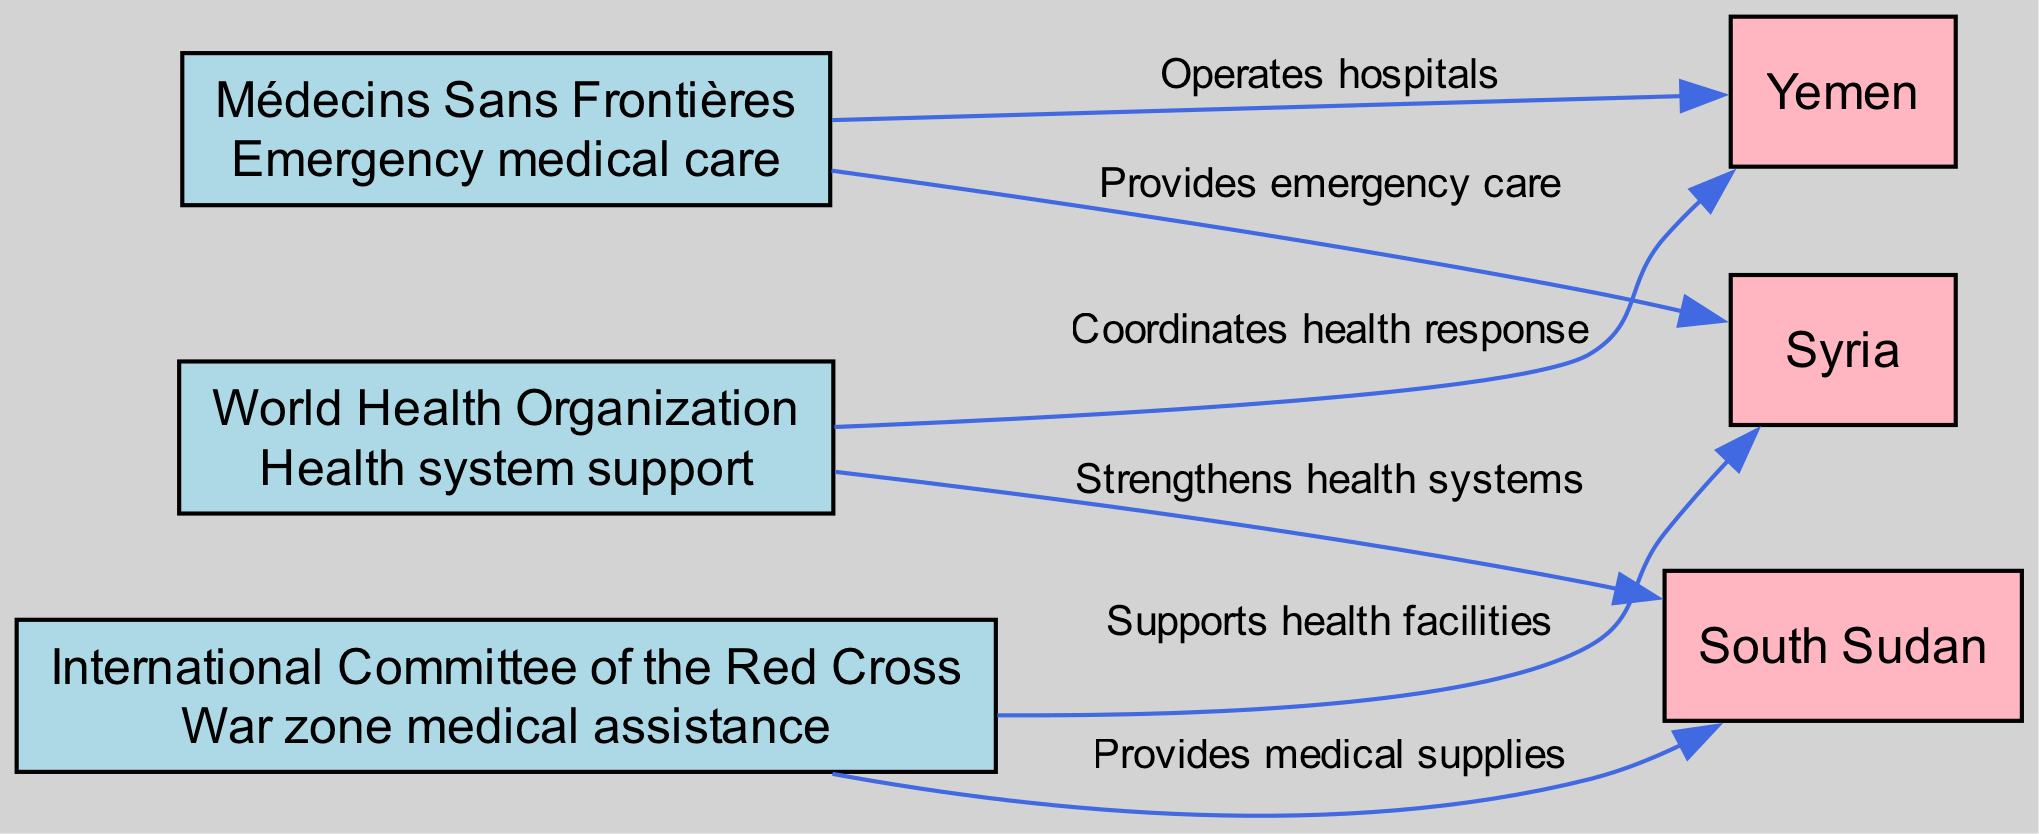What organizations provide medical aid in Syria? From the diagram, both Médecins Sans Frontières and the International Committee of the Red Cross have edges indicating they provide medical aid in Syria. MSF provides emergency care, and ICRC supports health facilities.
Answer: Médecins Sans Frontières, International Committee of the Red Cross How many conflict zones are represented in the diagram? The diagram includes three conflict zones: Syria, Yemen, and South Sudan. Counting these reveals a total of three distinct zones.
Answer: 3 Which organization coordinates health response in Yemen? The diagram shows an edge from the World Health Organization to Yemen labeled 'Coordinates health response', indicating that WHO takes this specific role in that region.
Answer: World Health Organization What type of medical specialization does Médecins Sans Frontières focus on? The diagram includes a label for MSF specifying its specialization as 'Emergency medical care'. This directly describes the role it plays in conflict zones.
Answer: Emergency medical care In which conflict zone does the ICRC provide medical supplies? According to the diagram, the edge from ICRC to South Sudan is labeled 'Provides medical supplies', directly indicating the region in which ICRC offers this aid.
Answer: South Sudan Which organization is responsible for strengthening health systems in South Sudan? The diagram indicates that the World Health Organization has an edge that states 'Strengthens health systems' towards South Sudan, indicating their specific responsibility in that area.
Answer: World Health Organization What is the main reach of the WHO as represented in the diagram? The diagram lists WHO with a reach labeled as 'Global', confirming that their efforts extend to a worldwide scale, affecting multiple conflict zones and regions.
Answer: Global Which organization operates hospitals in Yemen? The diagram shows an edge from Médecins Sans Frontières to Yemen with the label 'Operates hospitals', indicating their direct action in that conflict zone.
Answer: Médecins Sans Frontières 